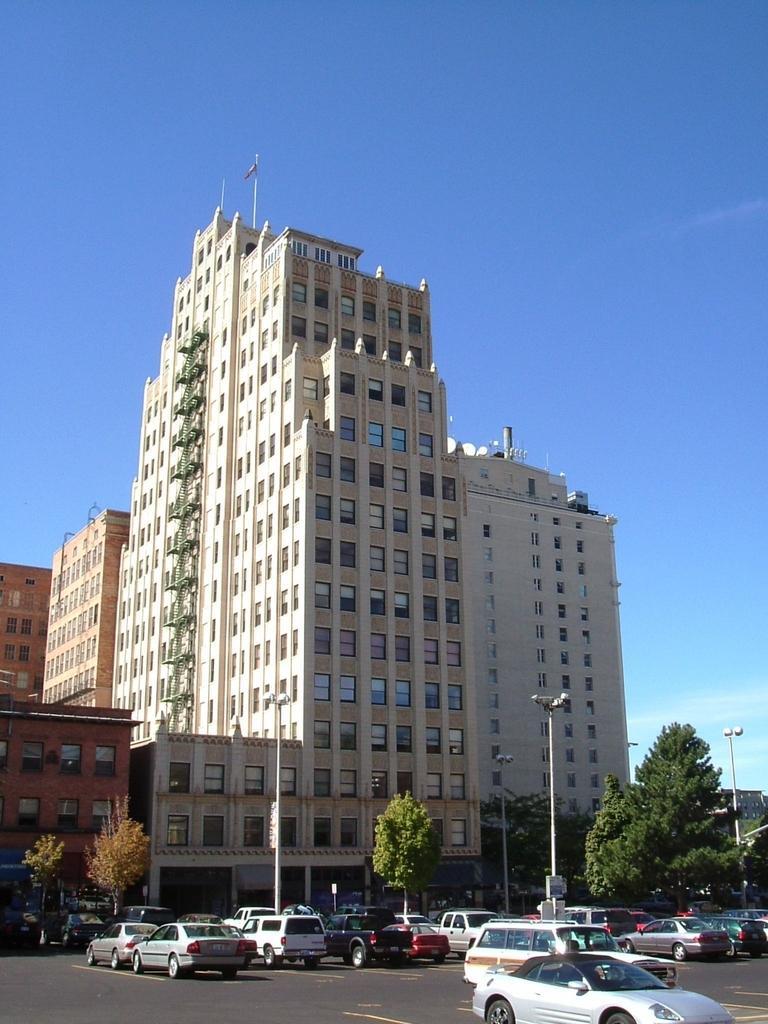Can you describe this image briefly? In this picture we can see there are some vehicles on the road. Behind the vehicles there are trees and poles with lights. Behind the poles there are buildings and the sky. 